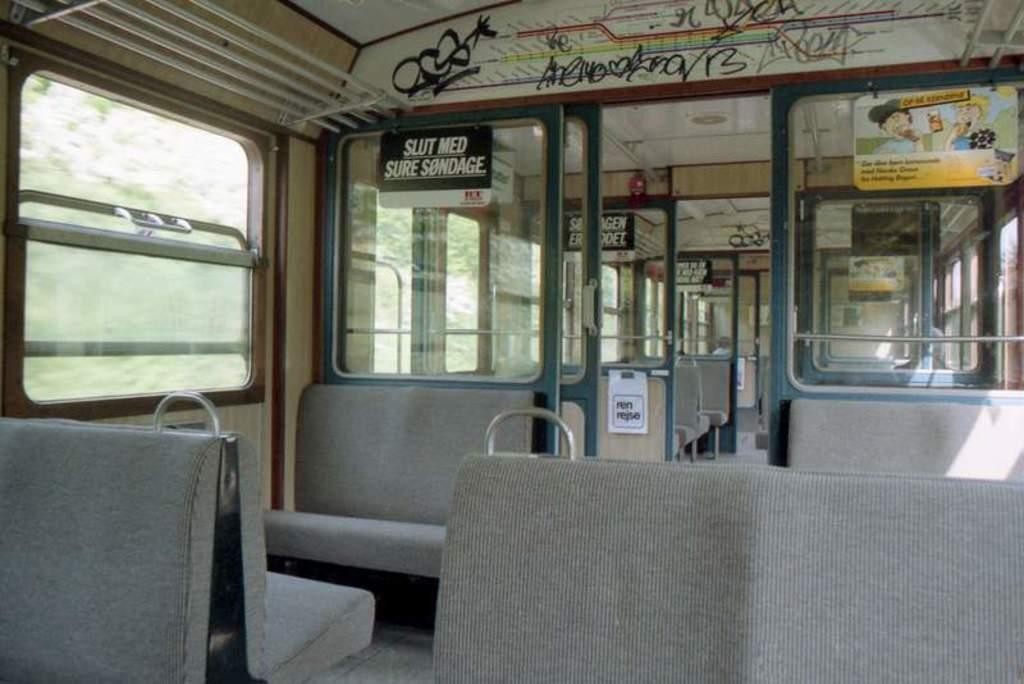What is the main subject of the image? The image depicts a vehicle. What can be found inside the vehicle? There are seats inside the vehicle. Are there any additional items inside the vehicle? Yes, there are boards with text in the vehicle. What can be seen through the windows of the vehicle? Trees are visible behind the windows of the vehicle. Can you see a whip hanging from the rearview mirror in the image? There is no mention of a whip or a rearview mirror in the provided facts, so it cannot be determined if one is present in the image. 